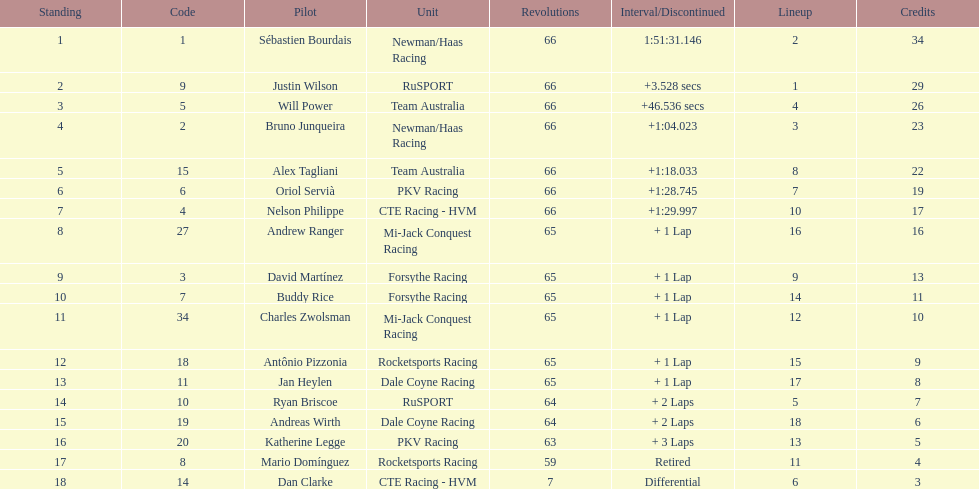At the 2006 gran premio telmex, who finished last? Dan Clarke. 